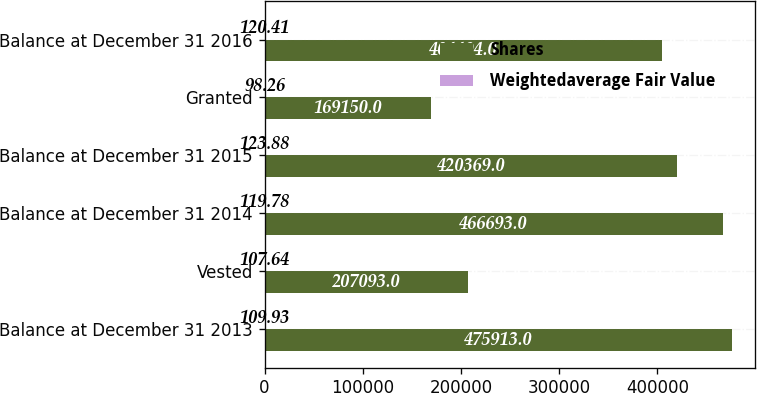<chart> <loc_0><loc_0><loc_500><loc_500><stacked_bar_chart><ecel><fcel>Balance at December 31 2013<fcel>Vested<fcel>Balance at December 31 2014<fcel>Balance at December 31 2015<fcel>Granted<fcel>Balance at December 31 2016<nl><fcel>Shares<fcel>475913<fcel>207093<fcel>466693<fcel>420369<fcel>169150<fcel>404494<nl><fcel>Weightedaverage Fair Value<fcel>109.93<fcel>107.64<fcel>119.78<fcel>123.88<fcel>98.26<fcel>120.41<nl></chart> 